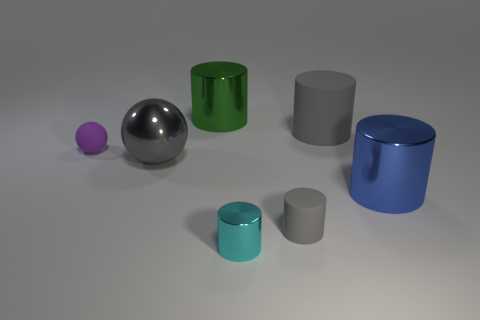What is the shape of the large metallic thing that is the same color as the tiny rubber cylinder?
Keep it short and to the point. Sphere. Do the large ball and the large rubber cylinder have the same color?
Ensure brevity in your answer.  Yes. There is a cyan thing that is the same shape as the big green thing; what is its size?
Your answer should be very brief. Small. Are there fewer rubber things that are behind the cyan cylinder than cylinders?
Your answer should be very brief. Yes. What size is the cyan cylinder that is to the right of the purple rubber sphere?
Offer a terse response. Small. What color is the other big rubber thing that is the same shape as the cyan object?
Your response must be concise. Gray. How many metallic spheres are the same color as the small metallic cylinder?
Offer a very short reply. 0. Is there a metal cylinder that is in front of the large gray object that is left of the cyan metal object in front of the tiny sphere?
Offer a terse response. Yes. What number of gray cylinders have the same material as the large blue thing?
Provide a short and direct response. 0. There is a green metal cylinder behind the big metallic sphere; does it have the same size as the gray object left of the tiny rubber cylinder?
Your answer should be very brief. Yes. 